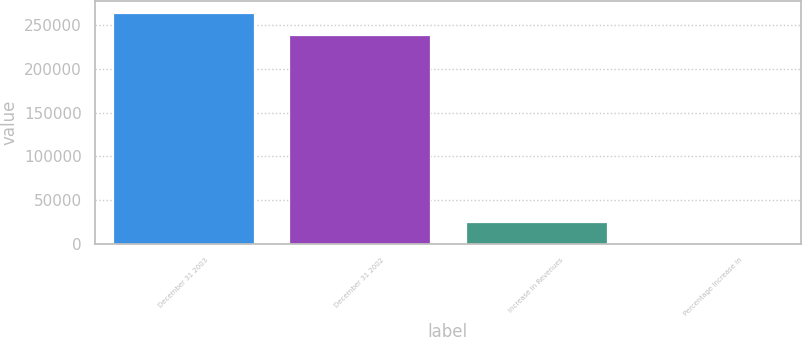<chart> <loc_0><loc_0><loc_500><loc_500><bar_chart><fcel>December 31 2003<fcel>December 31 2002<fcel>Increase in Revenues<fcel>Percentage Increase in<nl><fcel>264195<fcel>239081<fcel>25118.6<fcel>5<nl></chart> 